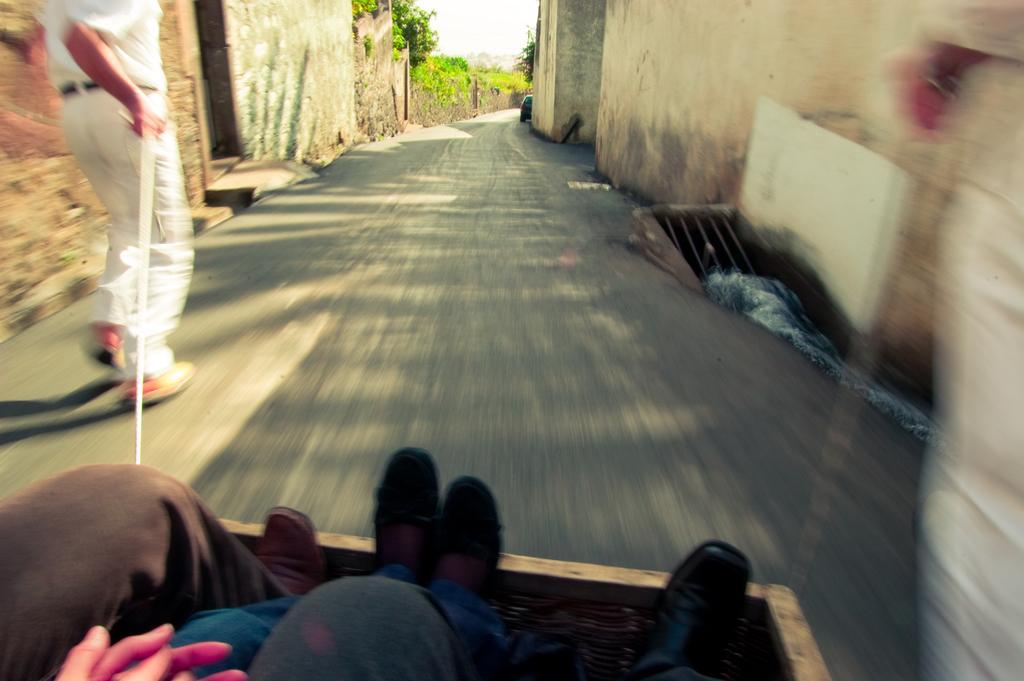Describe this image in one or two sentences. In the image we can see there are people sitting in the basket and a person is holding a rope in his hand. Behind there are is a vehicle parked on the road and there are buildings and trees in the area. 